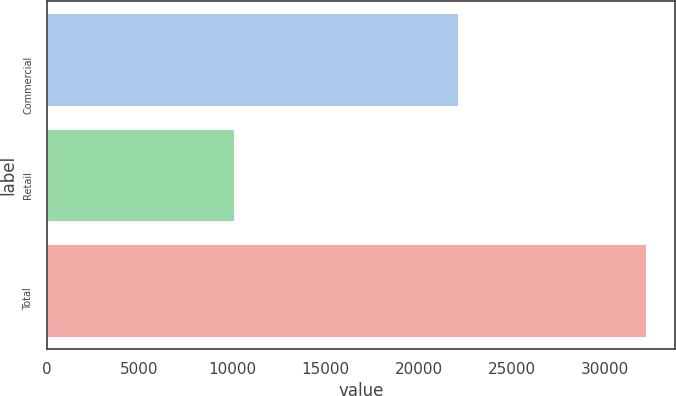<chart> <loc_0><loc_0><loc_500><loc_500><bar_chart><fcel>Commercial<fcel>Retail<fcel>Total<nl><fcel>22106<fcel>10073.8<fcel>32179.8<nl></chart> 